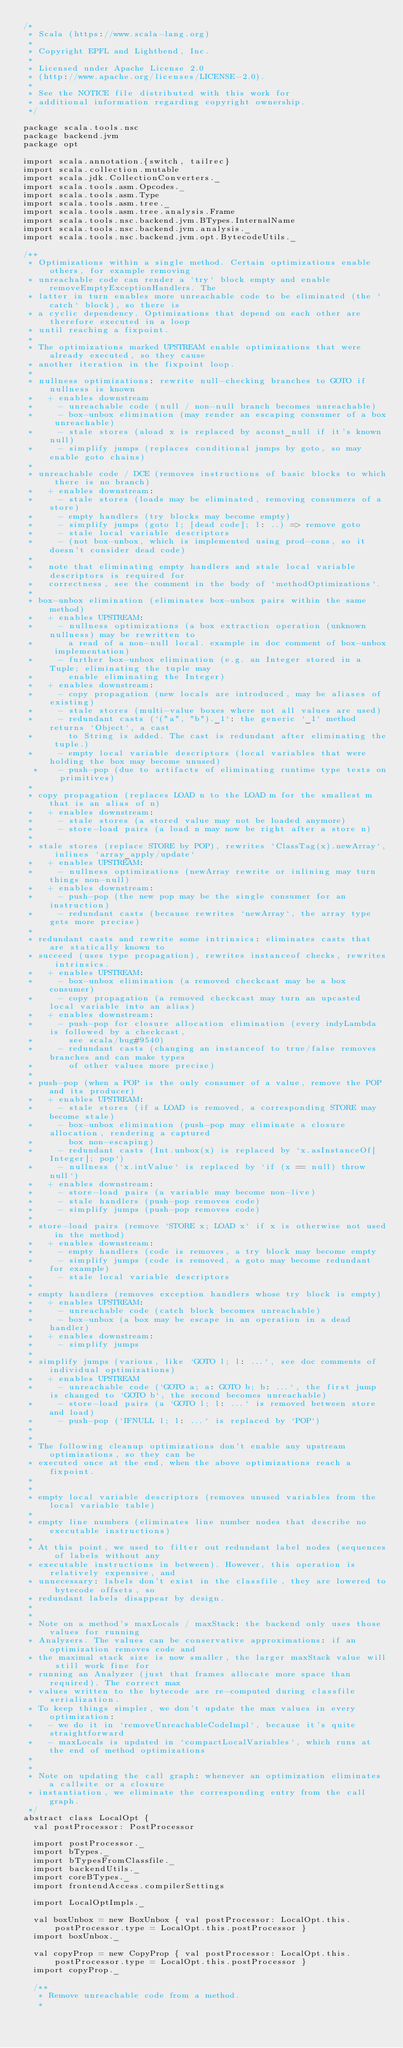<code> <loc_0><loc_0><loc_500><loc_500><_Scala_>/*
 * Scala (https://www.scala-lang.org)
 *
 * Copyright EPFL and Lightbend, Inc.
 *
 * Licensed under Apache License 2.0
 * (http://www.apache.org/licenses/LICENSE-2.0).
 *
 * See the NOTICE file distributed with this work for
 * additional information regarding copyright ownership.
 */

package scala.tools.nsc
package backend.jvm
package opt

import scala.annotation.{switch, tailrec}
import scala.collection.mutable
import scala.jdk.CollectionConverters._
import scala.tools.asm.Opcodes._
import scala.tools.asm.Type
import scala.tools.asm.tree._
import scala.tools.asm.tree.analysis.Frame
import scala.tools.nsc.backend.jvm.BTypes.InternalName
import scala.tools.nsc.backend.jvm.analysis._
import scala.tools.nsc.backend.jvm.opt.BytecodeUtils._

/**
 * Optimizations within a single method. Certain optimizations enable others, for example removing
 * unreachable code can render a `try` block empty and enable removeEmptyExceptionHandlers. The
 * latter in turn enables more unreachable code to be eliminated (the `catch` block), so there is
 * a cyclic dependency. Optimizations that depend on each other are therefore executed in a loop
 * until reaching a fixpoint.
 *
 * The optimizations marked UPSTREAM enable optimizations that were already executed, so they cause
 * another iteration in the fixpoint loop.
 *
 * nullness optimizations: rewrite null-checking branches to GOTO if nullness is known
 *   + enables downstream
 *     - unreachable code (null / non-null branch becomes unreachable)
 *     - box-unbox elimination (may render an escaping consumer of a box unreachable)
 *     - stale stores (aload x is replaced by aconst_null if it's known null)
 *     - simplify jumps (replaces conditional jumps by goto, so may enable goto chains)
 *
 * unreachable code / DCE (removes instructions of basic blocks to which there is no branch)
 *   + enables downstream:
 *     - stale stores (loads may be eliminated, removing consumers of a store)
 *     - empty handlers (try blocks may become empty)
 *     - simplify jumps (goto l; [dead code]; l: ..) => remove goto
 *     - stale local variable descriptors
 *     - (not box-unbox, which is implemented using prod-cons, so it doesn't consider dead code)
 *
 *   note that eliminating empty handlers and stale local variable descriptors is required for
 *   correctness, see the comment in the body of `methodOptimizations`.
 *
 * box-unbox elimination (eliminates box-unbox pairs within the same method)
 *   + enables UPSTREAM:
 *     - nullness optimizations (a box extraction operation (unknown nullness) may be rewritten to
 *       a read of a non-null local. example in doc comment of box-unbox implementation)
 *     - further box-unbox elimination (e.g. an Integer stored in a Tuple; eliminating the tuple may
 *       enable eliminating the Integer)
 *   + enables downstream:
 *     - copy propagation (new locals are introduced, may be aliases of existing)
 *     - stale stores (multi-value boxes where not all values are used)
 *     - redundant casts (`("a", "b")._1`: the generic `_1` method returns `Object`, a cast
 *       to String is added. The cast is redundant after eliminating the tuple.)
 *     - empty local variable descriptors (local variables that were holding the box may become unused)
  *    - push-pop (due to artifacts of eliminating runtime type tests on primitives)
 *
 * copy propagation (replaces LOAD n to the LOAD m for the smallest m that is an alias of n)
 *   + enables downstream:
 *     - stale stores (a stored value may not be loaded anymore)
 *     - store-load pairs (a load n may now be right after a store n)
 *
 * stale stores (replace STORE by POP), rewrites `ClassTag(x).newArray`, inlines `array_apply/update`
 *   + enables UPSTREAM:
 *     - nullness optimizations (newArray rewrite or inlining may turn things non-null)
 *   + enables downstream:
 *     - push-pop (the new pop may be the single consumer for an instruction)
 *     - redundant casts (because rewrites `newArray`, the array type gets more precise)
 *
 * redundant casts and rewrite some intrinsics: eliminates casts that are statically known to
 * succeed (uses type propagation), rewrites instanceof checks, rewrites intrinsics.
 *   + enables UPSTREAM:
 *     - box-unbox elimination (a removed checkcast may be a box consumer)
 *     - copy propagation (a removed checkcast may turn an upcasted local variable into an alias)
 *   + enables downstream:
 *     - push-pop for closure allocation elimination (every indyLambda is followed by a checkcast,
 *       see scala/bug#9540)
 *     - redundant casts (changing an instanceof to true/false removes branches and can make types
 *       of other values more precise)
 *
 * push-pop (when a POP is the only consumer of a value, remove the POP and its producer)
 *   + enables UPSTREAM:
 *     - stale stores (if a LOAD is removed, a corresponding STORE may become stale)
 *     - box-unbox elimination (push-pop may eliminate a closure allocation, rendering a captured
 *       box non-escaping)
 *     - redundant casts (Int.unbox(x) is replaced by `x.asInstanceOf[Integer]; pop`)
 *     - nullness (`x.intValue` is replaced by `if (x == null) throw null`)
 *   + enables downstream:
 *     - store-load pairs (a variable may become non-live)
 *     - stale handlers (push-pop removes code)
 *     - simplify jumps (push-pop removes code)
 *
 * store-load pairs (remove `STORE x; LOAD x` if x is otherwise not used in the method)
 *   + enables downstream:
 *     - empty handlers (code is removes, a try block may become empty
 *     - simplify jumps (code is removed, a goto may become redundant for example)
 *     - stale local variable descriptors
 *
 * empty handlers (removes exception handlers whose try block is empty)
 *   + enables UPSTREAM:
 *     - unreachable code (catch block becomes unreachable)
 *     - box-unbox (a box may be escape in an operation in a dead handler)
 *   + enables downstream:
 *     - simplify jumps
 *
 * simplify jumps (various, like `GOTO l; l: ...`, see doc comments of individual optimizations)
 *   + enables UPSTREAM
 *     - unreachable code (`GOTO a; a: GOTO b; b: ...`, the first jump is changed to `GOTO b`, the second becomes unreachable)
 *     - store-load pairs (a `GOTO l; l: ...` is removed between store and load)
 *     - push-pop (`IFNULL l; l: ...` is replaced by `POP`)
 *
 *
 * The following cleanup optimizations don't enable any upstream optimizations, so they can be
 * executed once at the end, when the above optimizations reach a fixpoint.
 *
 *
 * empty local variable descriptors (removes unused variables from the local variable table)
 *
 * empty line numbers (eliminates line number nodes that describe no executable instructions)
 *
 * At this point, we used to filter out redundant label nodes (sequences of labels without any
 * executable instructions in between). However, this operation is relatively expensive, and
 * unnecessary: labels don't exist in the classfile, they are lowered to bytecode offsets, so
 * redundant labels disappear by design.
 *
 *
 * Note on a method's maxLocals / maxStack: the backend only uses those values for running
 * Analyzers. The values can be conservative approximations: if an optimization removes code and
 * the maximal stack size is now smaller, the larger maxStack value will still work fine for
 * running an Analyzer (just that frames allocate more space than required). The correct max
 * values written to the bytecode are re-computed during classfile serialization.
 * To keep things simpler, we don't update the max values in every optimization:
 *   - we do it in `removeUnreachableCodeImpl`, because it's quite straightforward
 *   - maxLocals is updated in `compactLocalVariables`, which runs at the end of method optimizations
 *
 *
 * Note on updating the call graph: whenever an optimization eliminates a callsite or a closure
 * instantiation, we eliminate the corresponding entry from the call graph.
 */
abstract class LocalOpt {
  val postProcessor: PostProcessor

  import postProcessor._
  import bTypes._
  import bTypesFromClassfile._
  import backendUtils._
  import coreBTypes._
  import frontendAccess.compilerSettings

  import LocalOptImpls._

  val boxUnbox = new BoxUnbox { val postProcessor: LocalOpt.this.postProcessor.type = LocalOpt.this.postProcessor }
  import boxUnbox._

  val copyProp = new CopyProp { val postProcessor: LocalOpt.this.postProcessor.type = LocalOpt.this.postProcessor }
  import copyProp._

  /**
   * Remove unreachable code from a method.
   *</code> 